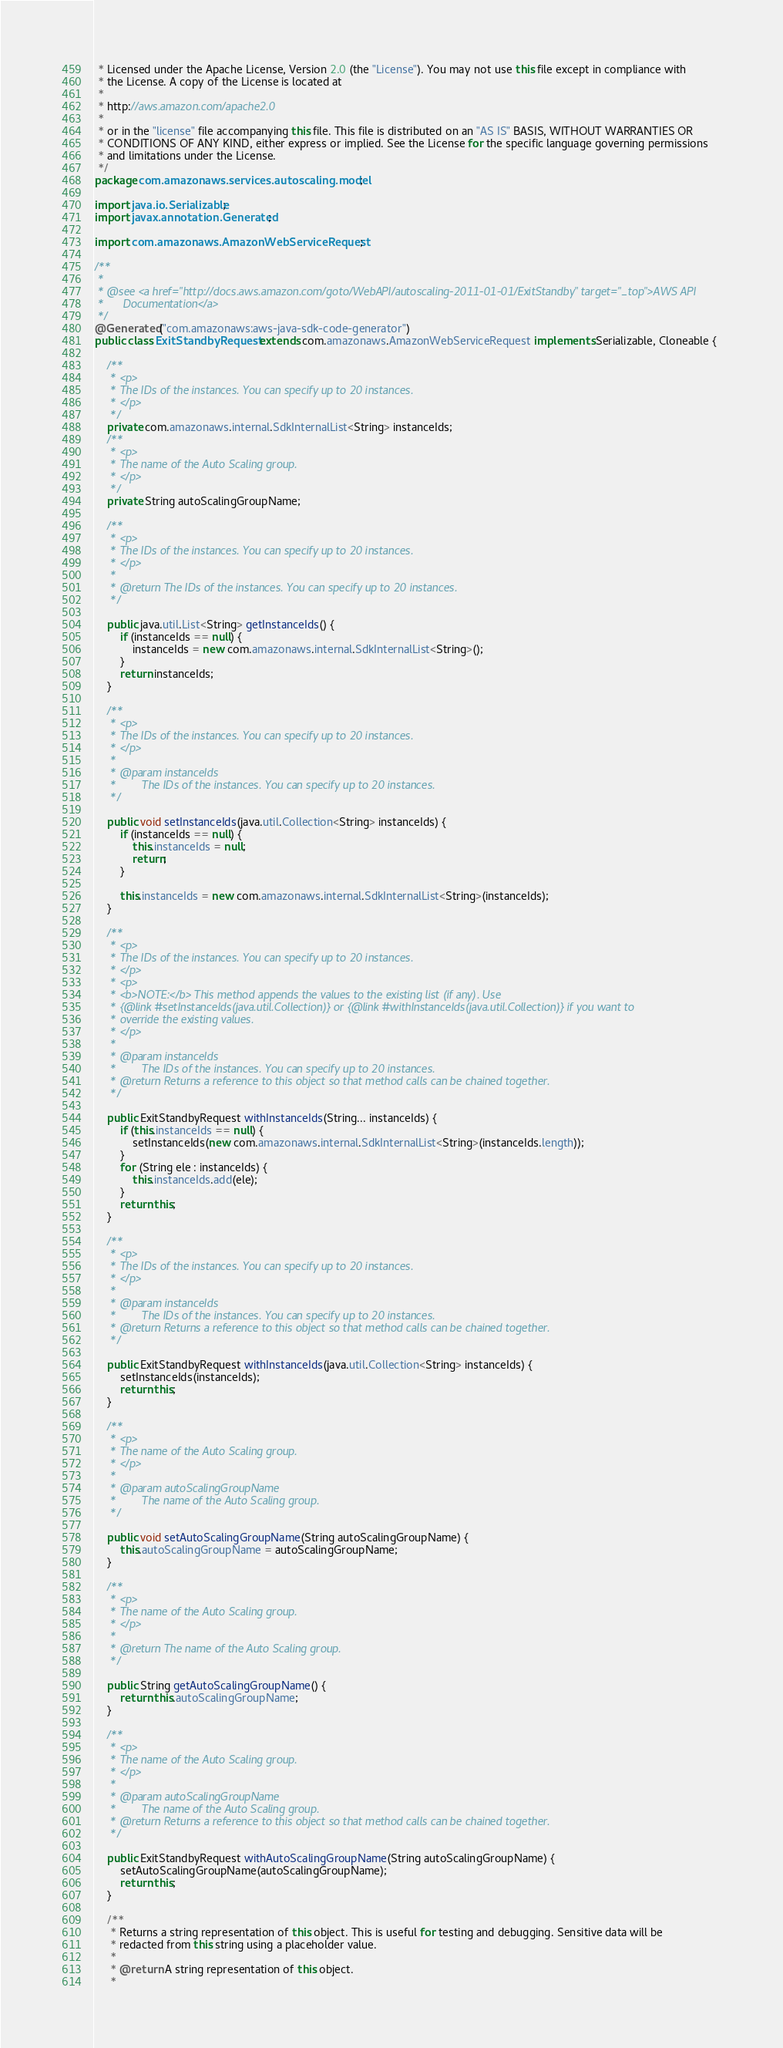<code> <loc_0><loc_0><loc_500><loc_500><_Java_> * Licensed under the Apache License, Version 2.0 (the "License"). You may not use this file except in compliance with
 * the License. A copy of the License is located at
 * 
 * http://aws.amazon.com/apache2.0
 * 
 * or in the "license" file accompanying this file. This file is distributed on an "AS IS" BASIS, WITHOUT WARRANTIES OR
 * CONDITIONS OF ANY KIND, either express or implied. See the License for the specific language governing permissions
 * and limitations under the License.
 */
package com.amazonaws.services.autoscaling.model;

import java.io.Serializable;
import javax.annotation.Generated;

import com.amazonaws.AmazonWebServiceRequest;

/**
 * 
 * @see <a href="http://docs.aws.amazon.com/goto/WebAPI/autoscaling-2011-01-01/ExitStandby" target="_top">AWS API
 *      Documentation</a>
 */
@Generated("com.amazonaws:aws-java-sdk-code-generator")
public class ExitStandbyRequest extends com.amazonaws.AmazonWebServiceRequest implements Serializable, Cloneable {

    /**
     * <p>
     * The IDs of the instances. You can specify up to 20 instances.
     * </p>
     */
    private com.amazonaws.internal.SdkInternalList<String> instanceIds;
    /**
     * <p>
     * The name of the Auto Scaling group.
     * </p>
     */
    private String autoScalingGroupName;

    /**
     * <p>
     * The IDs of the instances. You can specify up to 20 instances.
     * </p>
     * 
     * @return The IDs of the instances. You can specify up to 20 instances.
     */

    public java.util.List<String> getInstanceIds() {
        if (instanceIds == null) {
            instanceIds = new com.amazonaws.internal.SdkInternalList<String>();
        }
        return instanceIds;
    }

    /**
     * <p>
     * The IDs of the instances. You can specify up to 20 instances.
     * </p>
     * 
     * @param instanceIds
     *        The IDs of the instances. You can specify up to 20 instances.
     */

    public void setInstanceIds(java.util.Collection<String> instanceIds) {
        if (instanceIds == null) {
            this.instanceIds = null;
            return;
        }

        this.instanceIds = new com.amazonaws.internal.SdkInternalList<String>(instanceIds);
    }

    /**
     * <p>
     * The IDs of the instances. You can specify up to 20 instances.
     * </p>
     * <p>
     * <b>NOTE:</b> This method appends the values to the existing list (if any). Use
     * {@link #setInstanceIds(java.util.Collection)} or {@link #withInstanceIds(java.util.Collection)} if you want to
     * override the existing values.
     * </p>
     * 
     * @param instanceIds
     *        The IDs of the instances. You can specify up to 20 instances.
     * @return Returns a reference to this object so that method calls can be chained together.
     */

    public ExitStandbyRequest withInstanceIds(String... instanceIds) {
        if (this.instanceIds == null) {
            setInstanceIds(new com.amazonaws.internal.SdkInternalList<String>(instanceIds.length));
        }
        for (String ele : instanceIds) {
            this.instanceIds.add(ele);
        }
        return this;
    }

    /**
     * <p>
     * The IDs of the instances. You can specify up to 20 instances.
     * </p>
     * 
     * @param instanceIds
     *        The IDs of the instances. You can specify up to 20 instances.
     * @return Returns a reference to this object so that method calls can be chained together.
     */

    public ExitStandbyRequest withInstanceIds(java.util.Collection<String> instanceIds) {
        setInstanceIds(instanceIds);
        return this;
    }

    /**
     * <p>
     * The name of the Auto Scaling group.
     * </p>
     * 
     * @param autoScalingGroupName
     *        The name of the Auto Scaling group.
     */

    public void setAutoScalingGroupName(String autoScalingGroupName) {
        this.autoScalingGroupName = autoScalingGroupName;
    }

    /**
     * <p>
     * The name of the Auto Scaling group.
     * </p>
     * 
     * @return The name of the Auto Scaling group.
     */

    public String getAutoScalingGroupName() {
        return this.autoScalingGroupName;
    }

    /**
     * <p>
     * The name of the Auto Scaling group.
     * </p>
     * 
     * @param autoScalingGroupName
     *        The name of the Auto Scaling group.
     * @return Returns a reference to this object so that method calls can be chained together.
     */

    public ExitStandbyRequest withAutoScalingGroupName(String autoScalingGroupName) {
        setAutoScalingGroupName(autoScalingGroupName);
        return this;
    }

    /**
     * Returns a string representation of this object. This is useful for testing and debugging. Sensitive data will be
     * redacted from this string using a placeholder value.
     *
     * @return A string representation of this object.
     *</code> 